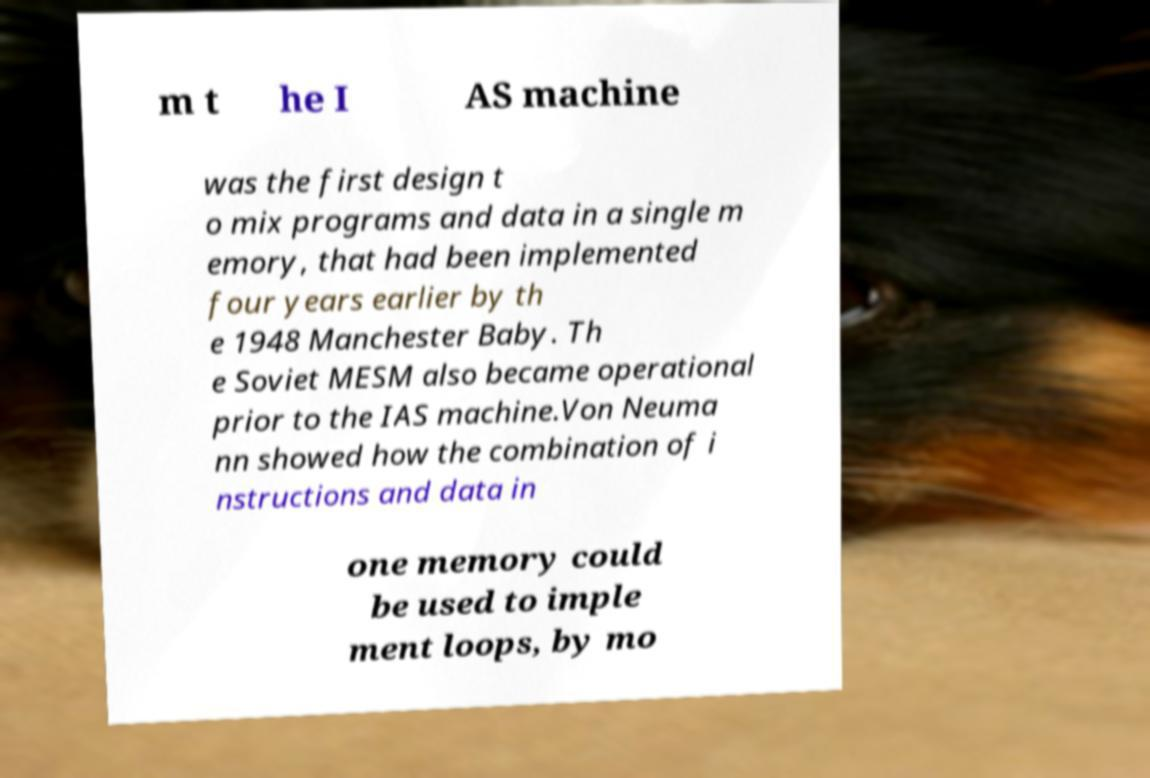There's text embedded in this image that I need extracted. Can you transcribe it verbatim? m t he I AS machine was the first design t o mix programs and data in a single m emory, that had been implemented four years earlier by th e 1948 Manchester Baby. Th e Soviet MESM also became operational prior to the IAS machine.Von Neuma nn showed how the combination of i nstructions and data in one memory could be used to imple ment loops, by mo 